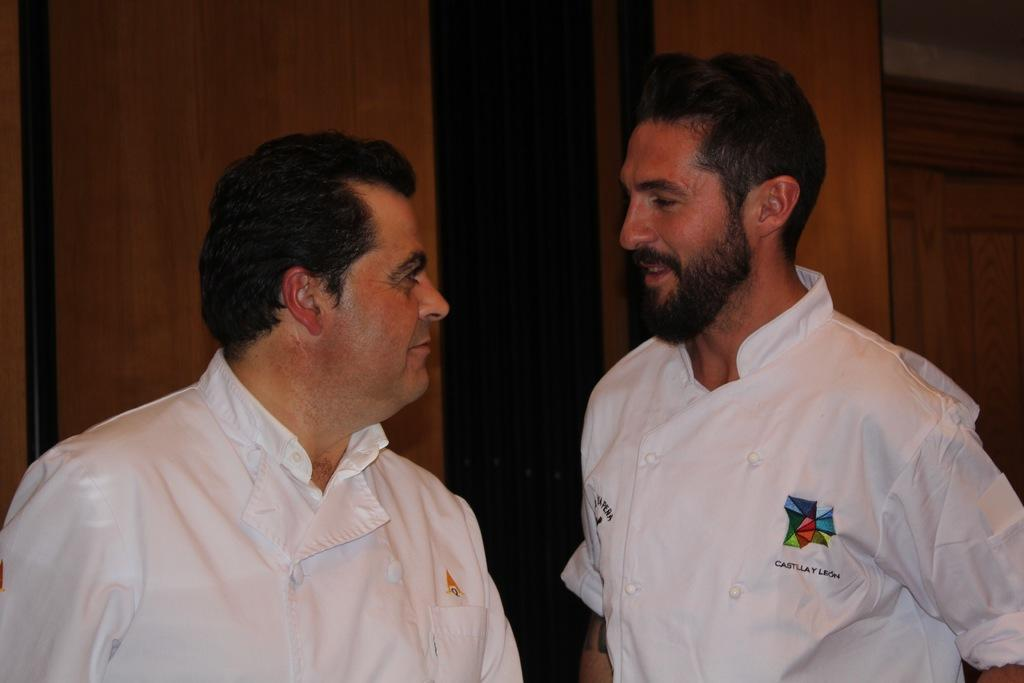How many people are present in the image? There are two persons in the image. What are the two persons doing in the image? The two persons are talking to each other. What type of oven can be seen in the background of the image? There is no oven present in the image; it only features two persons talking to each other. 